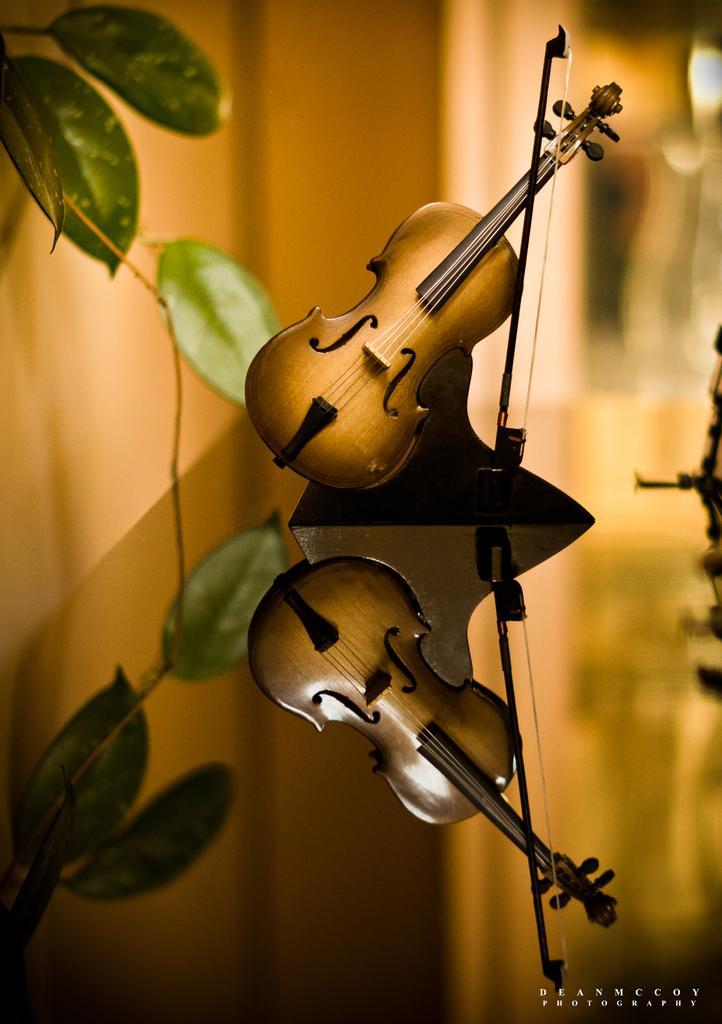Please provide a concise description of this image. In this picture we can see two violins and an object, here we can see leaves and in the background we can see it is blurry, in the bottom right we can see some text on it. 